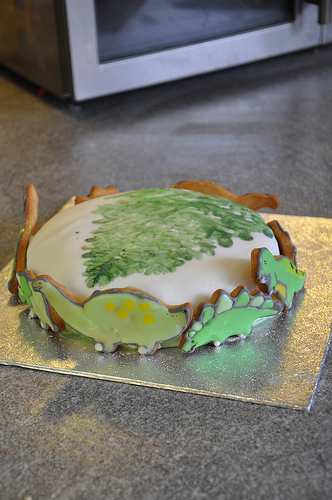<image>
Is the cake in the oven? No. The cake is not contained within the oven. These objects have a different spatial relationship. 